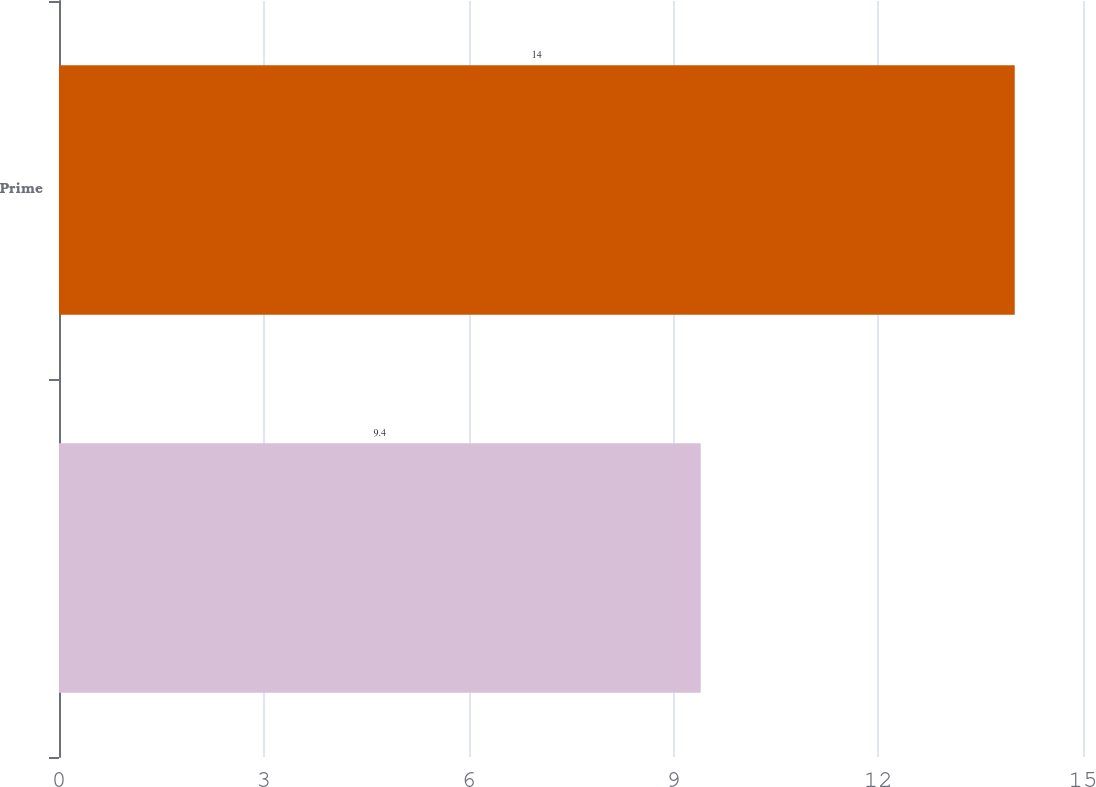Convert chart. <chart><loc_0><loc_0><loc_500><loc_500><bar_chart><ecel><fcel>Prime<nl><fcel>9.4<fcel>14<nl></chart> 